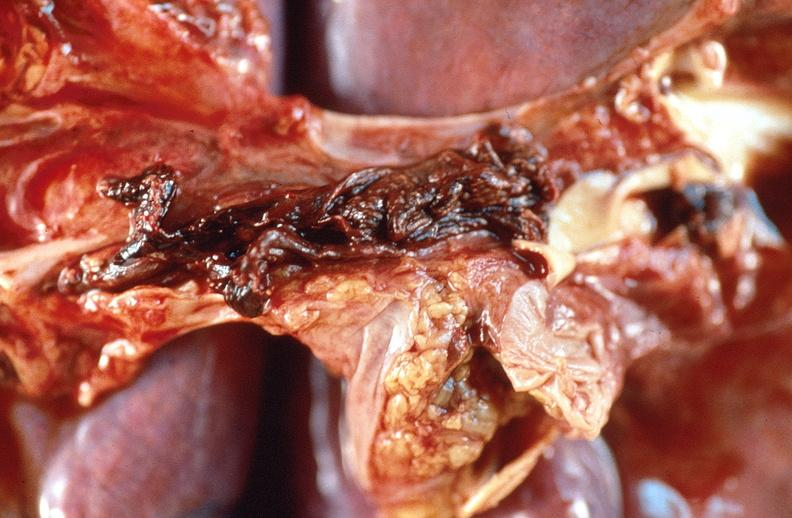what is present?
Answer the question using a single word or phrase. Respiratory 